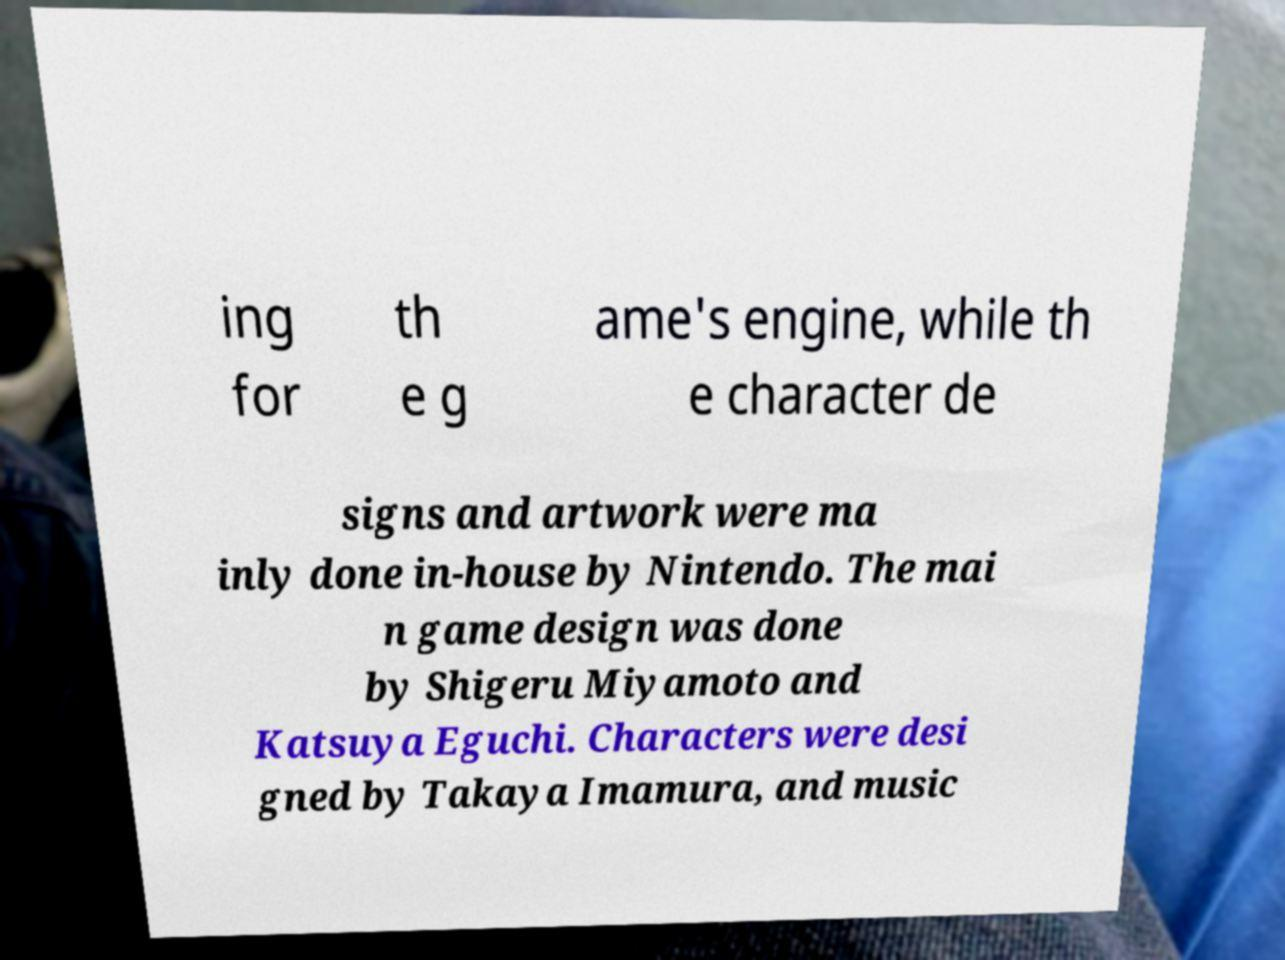There's text embedded in this image that I need extracted. Can you transcribe it verbatim? ing for th e g ame's engine, while th e character de signs and artwork were ma inly done in-house by Nintendo. The mai n game design was done by Shigeru Miyamoto and Katsuya Eguchi. Characters were desi gned by Takaya Imamura, and music 